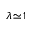Convert formula to latex. <formula><loc_0><loc_0><loc_500><loc_500>\lambda \, \simeq \, 1</formula> 